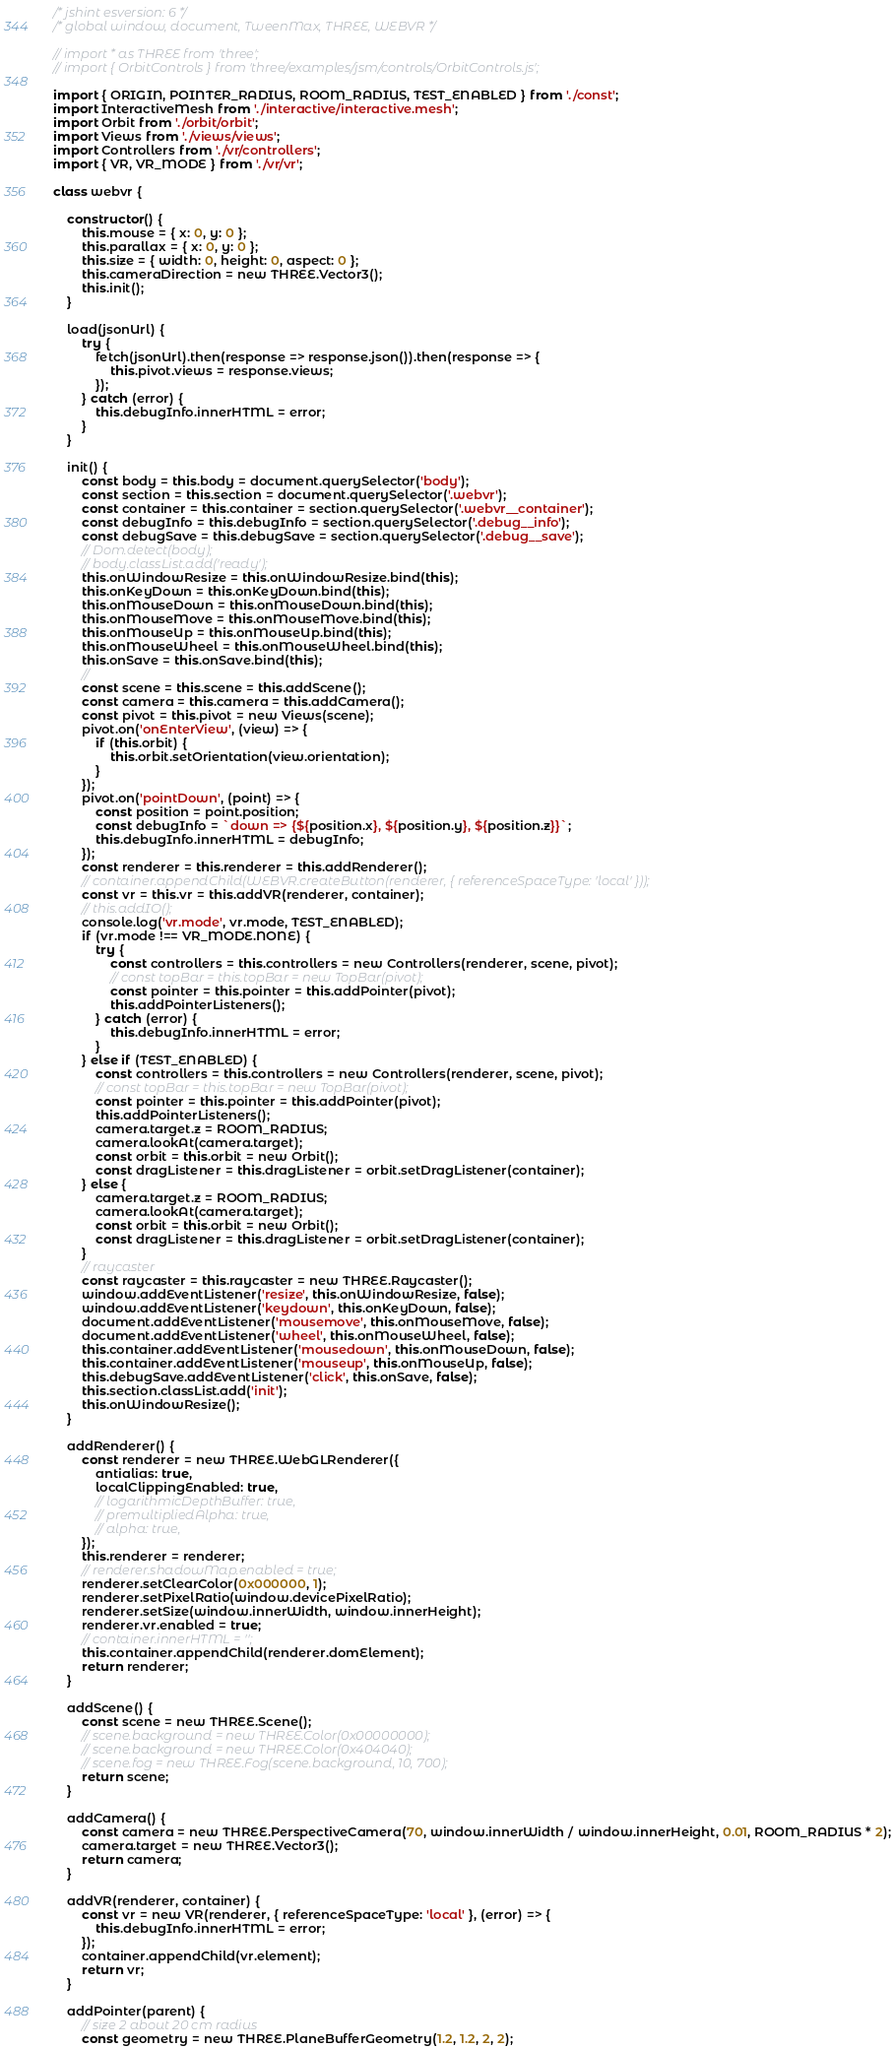Convert code to text. <code><loc_0><loc_0><loc_500><loc_500><_JavaScript_>/* jshint esversion: 6 */
/* global window, document, TweenMax, THREE, WEBVR */

// import * as THREE from 'three';
// import { OrbitControls } from 'three/examples/jsm/controls/OrbitControls.js';

import { ORIGIN, POINTER_RADIUS, ROOM_RADIUS, TEST_ENABLED } from './const';
import InteractiveMesh from './interactive/interactive.mesh';
import Orbit from './orbit/orbit';
import Views from './views/views';
import Controllers from './vr/controllers';
import { VR, VR_MODE } from './vr/vr';

class webvr {

	constructor() {
		this.mouse = { x: 0, y: 0 };
		this.parallax = { x: 0, y: 0 };
		this.size = { width: 0, height: 0, aspect: 0 };
		this.cameraDirection = new THREE.Vector3();
		this.init();
	}

	load(jsonUrl) {
		try {
			fetch(jsonUrl).then(response => response.json()).then(response => {
				this.pivot.views = response.views;
			});
		} catch (error) {
			this.debugInfo.innerHTML = error;
		}
	}

	init() {
		const body = this.body = document.querySelector('body');
		const section = this.section = document.querySelector('.webvr');
		const container = this.container = section.querySelector('.webvr__container');
		const debugInfo = this.debugInfo = section.querySelector('.debug__info');
		const debugSave = this.debugSave = section.querySelector('.debug__save');
		// Dom.detect(body);
		// body.classList.add('ready');
		this.onWindowResize = this.onWindowResize.bind(this);
		this.onKeyDown = this.onKeyDown.bind(this);
		this.onMouseDown = this.onMouseDown.bind(this);
		this.onMouseMove = this.onMouseMove.bind(this);
		this.onMouseUp = this.onMouseUp.bind(this);
		this.onMouseWheel = this.onMouseWheel.bind(this);
		this.onSave = this.onSave.bind(this);
		//
		const scene = this.scene = this.addScene();
		const camera = this.camera = this.addCamera();
		const pivot = this.pivot = new Views(scene);
		pivot.on('onEnterView', (view) => {
			if (this.orbit) {
				this.orbit.setOrientation(view.orientation);
			}
		});
		pivot.on('pointDown', (point) => {
			const position = point.position;
			const debugInfo = `down => {${position.x}, ${position.y}, ${position.z}}`;
			this.debugInfo.innerHTML = debugInfo;
		});
		const renderer = this.renderer = this.addRenderer();
		// container.appendChild(WEBVR.createButton(renderer, { referenceSpaceType: 'local' }));
		const vr = this.vr = this.addVR(renderer, container);
		// this.addIO();
		console.log('vr.mode', vr.mode, TEST_ENABLED);
		if (vr.mode !== VR_MODE.NONE) {
			try {
				const controllers = this.controllers = new Controllers(renderer, scene, pivot);
				// const topBar = this.topBar = new TopBar(pivot);
				const pointer = this.pointer = this.addPointer(pivot);
				this.addPointerListeners();
			} catch (error) {
				this.debugInfo.innerHTML = error;
			}
		} else if (TEST_ENABLED) {
			const controllers = this.controllers = new Controllers(renderer, scene, pivot);
			// const topBar = this.topBar = new TopBar(pivot);
			const pointer = this.pointer = this.addPointer(pivot);
			this.addPointerListeners();
			camera.target.z = ROOM_RADIUS;
			camera.lookAt(camera.target);
			const orbit = this.orbit = new Orbit();
			const dragListener = this.dragListener = orbit.setDragListener(container);
		} else {
			camera.target.z = ROOM_RADIUS;
			camera.lookAt(camera.target);
			const orbit = this.orbit = new Orbit();
			const dragListener = this.dragListener = orbit.setDragListener(container);
		}
		// raycaster
		const raycaster = this.raycaster = new THREE.Raycaster();
		window.addEventListener('resize', this.onWindowResize, false);
		window.addEventListener('keydown', this.onKeyDown, false);
		document.addEventListener('mousemove', this.onMouseMove, false);
		document.addEventListener('wheel', this.onMouseWheel, false);
		this.container.addEventListener('mousedown', this.onMouseDown, false);
		this.container.addEventListener('mouseup', this.onMouseUp, false);
		this.debugSave.addEventListener('click', this.onSave, false);
		this.section.classList.add('init');
		this.onWindowResize();
	}

	addRenderer() {
		const renderer = new THREE.WebGLRenderer({
			antialias: true,
			localClippingEnabled: true,
			// logarithmicDepthBuffer: true,
			// premultipliedAlpha: true,
			// alpha: true,
		});
		this.renderer = renderer;
		// renderer.shadowMap.enabled = true;
		renderer.setClearColor(0x000000, 1);
		renderer.setPixelRatio(window.devicePixelRatio);
		renderer.setSize(window.innerWidth, window.innerHeight);
		renderer.vr.enabled = true;
		// container.innerHTML = '';
		this.container.appendChild(renderer.domElement);
		return renderer;
	}

	addScene() {
		const scene = new THREE.Scene();
		// scene.background = new THREE.Color(0x00000000);
		// scene.background = new THREE.Color(0x404040);
		// scene.fog = new THREE.Fog(scene.background, 10, 700);
		return scene;
	}

	addCamera() {
		const camera = new THREE.PerspectiveCamera(70, window.innerWidth / window.innerHeight, 0.01, ROOM_RADIUS * 2);
		camera.target = new THREE.Vector3();
		return camera;
	}

	addVR(renderer, container) {
		const vr = new VR(renderer, { referenceSpaceType: 'local' }, (error) => {
			this.debugInfo.innerHTML = error;
		});
		container.appendChild(vr.element);
		return vr;
	}

	addPointer(parent) {
		// size 2 about 20 cm radius
		const geometry = new THREE.PlaneBufferGeometry(1.2, 1.2, 2, 2);</code> 